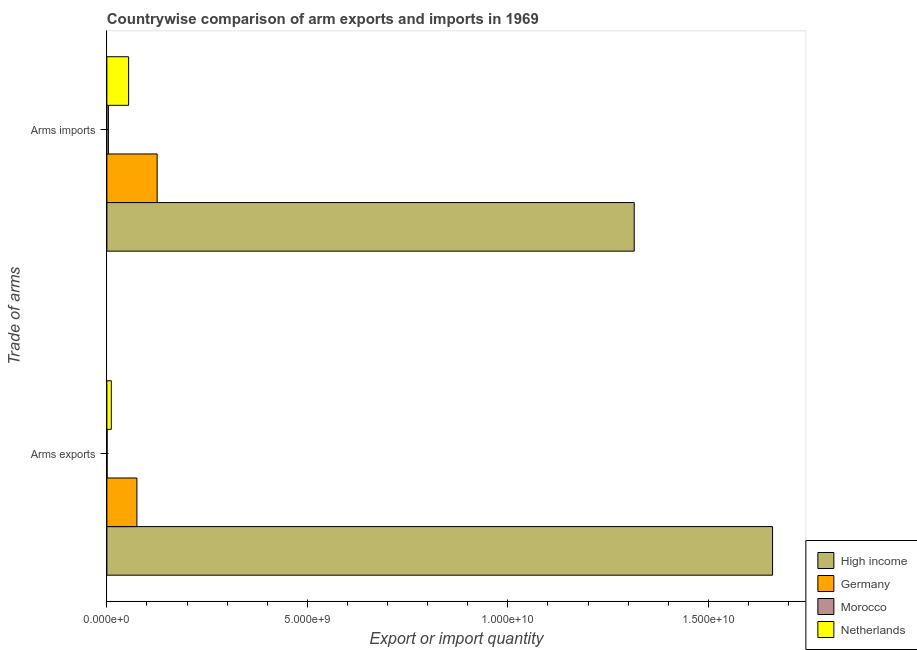Are the number of bars per tick equal to the number of legend labels?
Make the answer very short. Yes. How many bars are there on the 1st tick from the bottom?
Give a very brief answer. 4. What is the label of the 2nd group of bars from the top?
Give a very brief answer. Arms exports. What is the arms imports in Morocco?
Offer a terse response. 3.80e+07. Across all countries, what is the maximum arms imports?
Ensure brevity in your answer.  1.32e+1. Across all countries, what is the minimum arms imports?
Give a very brief answer. 3.80e+07. In which country was the arms exports maximum?
Your answer should be compact. High income. In which country was the arms exports minimum?
Your response must be concise. Morocco. What is the total arms exports in the graph?
Make the answer very short. 1.75e+1. What is the difference between the arms imports in High income and that in Netherlands?
Ensure brevity in your answer.  1.26e+1. What is the difference between the arms imports in Germany and the arms exports in Morocco?
Your answer should be very brief. 1.25e+09. What is the average arms imports per country?
Ensure brevity in your answer.  3.75e+09. What is the difference between the arms imports and arms exports in Germany?
Keep it short and to the point. 5.05e+08. What is the ratio of the arms exports in Netherlands to that in Germany?
Provide a short and direct response. 0.15. In how many countries, is the arms imports greater than the average arms imports taken over all countries?
Offer a terse response. 1. What does the 3rd bar from the top in Arms imports represents?
Your answer should be compact. Germany. What does the 3rd bar from the bottom in Arms exports represents?
Your answer should be very brief. Morocco. Does the graph contain any zero values?
Your answer should be compact. No. How many legend labels are there?
Ensure brevity in your answer.  4. What is the title of the graph?
Keep it short and to the point. Countrywise comparison of arm exports and imports in 1969. Does "High income: nonOECD" appear as one of the legend labels in the graph?
Ensure brevity in your answer.  No. What is the label or title of the X-axis?
Provide a short and direct response. Export or import quantity. What is the label or title of the Y-axis?
Ensure brevity in your answer.  Trade of arms. What is the Export or import quantity of High income in Arms exports?
Keep it short and to the point. 1.66e+1. What is the Export or import quantity in Germany in Arms exports?
Your answer should be compact. 7.49e+08. What is the Export or import quantity of Morocco in Arms exports?
Ensure brevity in your answer.  6.00e+06. What is the Export or import quantity of Netherlands in Arms exports?
Offer a very short reply. 1.11e+08. What is the Export or import quantity in High income in Arms imports?
Your response must be concise. 1.32e+1. What is the Export or import quantity of Germany in Arms imports?
Ensure brevity in your answer.  1.25e+09. What is the Export or import quantity in Morocco in Arms imports?
Your answer should be very brief. 3.80e+07. What is the Export or import quantity of Netherlands in Arms imports?
Make the answer very short. 5.42e+08. Across all Trade of arms, what is the maximum Export or import quantity of High income?
Offer a terse response. 1.66e+1. Across all Trade of arms, what is the maximum Export or import quantity of Germany?
Your answer should be compact. 1.25e+09. Across all Trade of arms, what is the maximum Export or import quantity of Morocco?
Make the answer very short. 3.80e+07. Across all Trade of arms, what is the maximum Export or import quantity of Netherlands?
Offer a very short reply. 5.42e+08. Across all Trade of arms, what is the minimum Export or import quantity in High income?
Make the answer very short. 1.32e+1. Across all Trade of arms, what is the minimum Export or import quantity in Germany?
Ensure brevity in your answer.  7.49e+08. Across all Trade of arms, what is the minimum Export or import quantity of Morocco?
Provide a short and direct response. 6.00e+06. Across all Trade of arms, what is the minimum Export or import quantity of Netherlands?
Make the answer very short. 1.11e+08. What is the total Export or import quantity in High income in the graph?
Keep it short and to the point. 2.98e+1. What is the total Export or import quantity in Germany in the graph?
Your answer should be compact. 2.00e+09. What is the total Export or import quantity in Morocco in the graph?
Offer a terse response. 4.40e+07. What is the total Export or import quantity in Netherlands in the graph?
Make the answer very short. 6.53e+08. What is the difference between the Export or import quantity in High income in Arms exports and that in Arms imports?
Give a very brief answer. 3.45e+09. What is the difference between the Export or import quantity in Germany in Arms exports and that in Arms imports?
Make the answer very short. -5.05e+08. What is the difference between the Export or import quantity in Morocco in Arms exports and that in Arms imports?
Offer a very short reply. -3.20e+07. What is the difference between the Export or import quantity in Netherlands in Arms exports and that in Arms imports?
Ensure brevity in your answer.  -4.31e+08. What is the difference between the Export or import quantity of High income in Arms exports and the Export or import quantity of Germany in Arms imports?
Give a very brief answer. 1.53e+1. What is the difference between the Export or import quantity in High income in Arms exports and the Export or import quantity in Morocco in Arms imports?
Provide a short and direct response. 1.66e+1. What is the difference between the Export or import quantity in High income in Arms exports and the Export or import quantity in Netherlands in Arms imports?
Give a very brief answer. 1.61e+1. What is the difference between the Export or import quantity of Germany in Arms exports and the Export or import quantity of Morocco in Arms imports?
Offer a very short reply. 7.11e+08. What is the difference between the Export or import quantity of Germany in Arms exports and the Export or import quantity of Netherlands in Arms imports?
Give a very brief answer. 2.07e+08. What is the difference between the Export or import quantity in Morocco in Arms exports and the Export or import quantity in Netherlands in Arms imports?
Your response must be concise. -5.36e+08. What is the average Export or import quantity in High income per Trade of arms?
Your answer should be compact. 1.49e+1. What is the average Export or import quantity of Germany per Trade of arms?
Make the answer very short. 1.00e+09. What is the average Export or import quantity in Morocco per Trade of arms?
Keep it short and to the point. 2.20e+07. What is the average Export or import quantity in Netherlands per Trade of arms?
Your answer should be very brief. 3.26e+08. What is the difference between the Export or import quantity in High income and Export or import quantity in Germany in Arms exports?
Your answer should be very brief. 1.59e+1. What is the difference between the Export or import quantity of High income and Export or import quantity of Morocco in Arms exports?
Offer a terse response. 1.66e+1. What is the difference between the Export or import quantity of High income and Export or import quantity of Netherlands in Arms exports?
Give a very brief answer. 1.65e+1. What is the difference between the Export or import quantity of Germany and Export or import quantity of Morocco in Arms exports?
Provide a short and direct response. 7.43e+08. What is the difference between the Export or import quantity in Germany and Export or import quantity in Netherlands in Arms exports?
Offer a very short reply. 6.38e+08. What is the difference between the Export or import quantity in Morocco and Export or import quantity in Netherlands in Arms exports?
Your answer should be compact. -1.05e+08. What is the difference between the Export or import quantity in High income and Export or import quantity in Germany in Arms imports?
Keep it short and to the point. 1.19e+1. What is the difference between the Export or import quantity in High income and Export or import quantity in Morocco in Arms imports?
Provide a short and direct response. 1.31e+1. What is the difference between the Export or import quantity in High income and Export or import quantity in Netherlands in Arms imports?
Offer a very short reply. 1.26e+1. What is the difference between the Export or import quantity in Germany and Export or import quantity in Morocco in Arms imports?
Make the answer very short. 1.22e+09. What is the difference between the Export or import quantity of Germany and Export or import quantity of Netherlands in Arms imports?
Provide a succinct answer. 7.12e+08. What is the difference between the Export or import quantity of Morocco and Export or import quantity of Netherlands in Arms imports?
Provide a short and direct response. -5.04e+08. What is the ratio of the Export or import quantity in High income in Arms exports to that in Arms imports?
Give a very brief answer. 1.26. What is the ratio of the Export or import quantity in Germany in Arms exports to that in Arms imports?
Make the answer very short. 0.6. What is the ratio of the Export or import quantity in Morocco in Arms exports to that in Arms imports?
Offer a terse response. 0.16. What is the ratio of the Export or import quantity in Netherlands in Arms exports to that in Arms imports?
Ensure brevity in your answer.  0.2. What is the difference between the highest and the second highest Export or import quantity in High income?
Your answer should be compact. 3.45e+09. What is the difference between the highest and the second highest Export or import quantity of Germany?
Offer a terse response. 5.05e+08. What is the difference between the highest and the second highest Export or import quantity in Morocco?
Your response must be concise. 3.20e+07. What is the difference between the highest and the second highest Export or import quantity in Netherlands?
Your response must be concise. 4.31e+08. What is the difference between the highest and the lowest Export or import quantity in High income?
Your answer should be compact. 3.45e+09. What is the difference between the highest and the lowest Export or import quantity of Germany?
Give a very brief answer. 5.05e+08. What is the difference between the highest and the lowest Export or import quantity in Morocco?
Your response must be concise. 3.20e+07. What is the difference between the highest and the lowest Export or import quantity of Netherlands?
Give a very brief answer. 4.31e+08. 